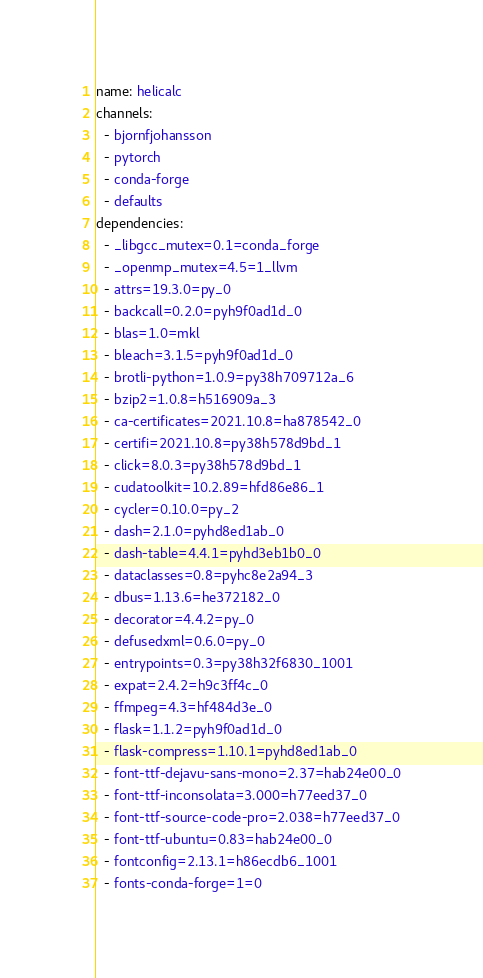<code> <loc_0><loc_0><loc_500><loc_500><_YAML_>name: helicalc
channels:
  - bjornfjohansson
  - pytorch
  - conda-forge
  - defaults
dependencies:
  - _libgcc_mutex=0.1=conda_forge
  - _openmp_mutex=4.5=1_llvm
  - attrs=19.3.0=py_0
  - backcall=0.2.0=pyh9f0ad1d_0
  - blas=1.0=mkl
  - bleach=3.1.5=pyh9f0ad1d_0
  - brotli-python=1.0.9=py38h709712a_6
  - bzip2=1.0.8=h516909a_3
  - ca-certificates=2021.10.8=ha878542_0
  - certifi=2021.10.8=py38h578d9bd_1
  - click=8.0.3=py38h578d9bd_1
  - cudatoolkit=10.2.89=hfd86e86_1
  - cycler=0.10.0=py_2
  - dash=2.1.0=pyhd8ed1ab_0
  - dash-table=4.4.1=pyhd3eb1b0_0
  - dataclasses=0.8=pyhc8e2a94_3
  - dbus=1.13.6=he372182_0
  - decorator=4.4.2=py_0
  - defusedxml=0.6.0=py_0
  - entrypoints=0.3=py38h32f6830_1001
  - expat=2.4.2=h9c3ff4c_0
  - ffmpeg=4.3=hf484d3e_0
  - flask=1.1.2=pyh9f0ad1d_0
  - flask-compress=1.10.1=pyhd8ed1ab_0
  - font-ttf-dejavu-sans-mono=2.37=hab24e00_0
  - font-ttf-inconsolata=3.000=h77eed37_0
  - font-ttf-source-code-pro=2.038=h77eed37_0
  - font-ttf-ubuntu=0.83=hab24e00_0
  - fontconfig=2.13.1=h86ecdb6_1001
  - fonts-conda-forge=1=0</code> 